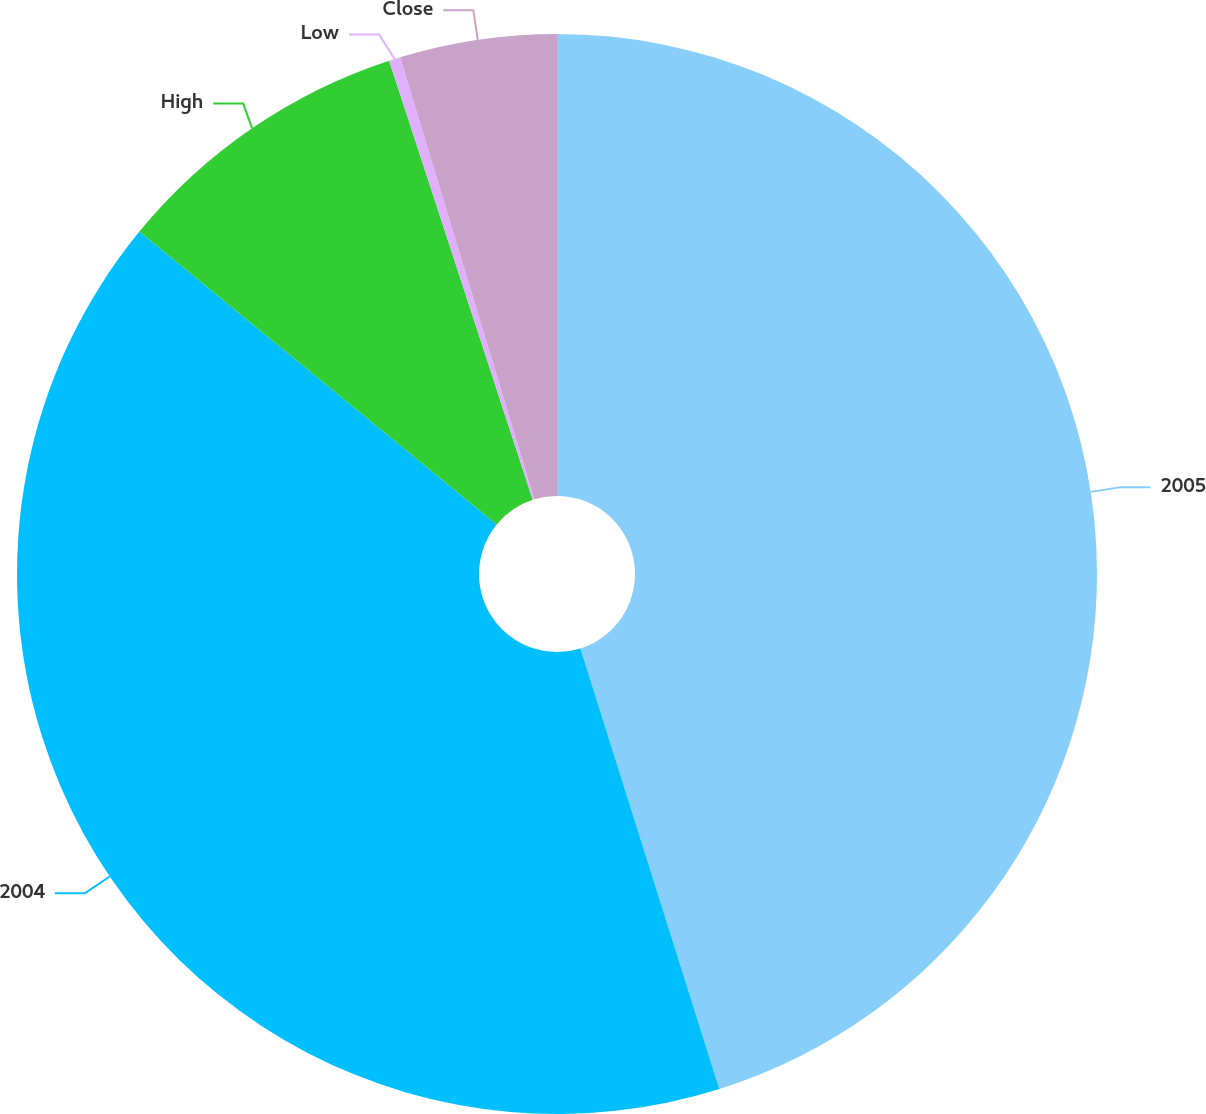Convert chart. <chart><loc_0><loc_0><loc_500><loc_500><pie_chart><fcel>2005<fcel>2004<fcel>High<fcel>Low<fcel>Close<nl><fcel>45.14%<fcel>40.79%<fcel>9.04%<fcel>0.34%<fcel>4.69%<nl></chart> 